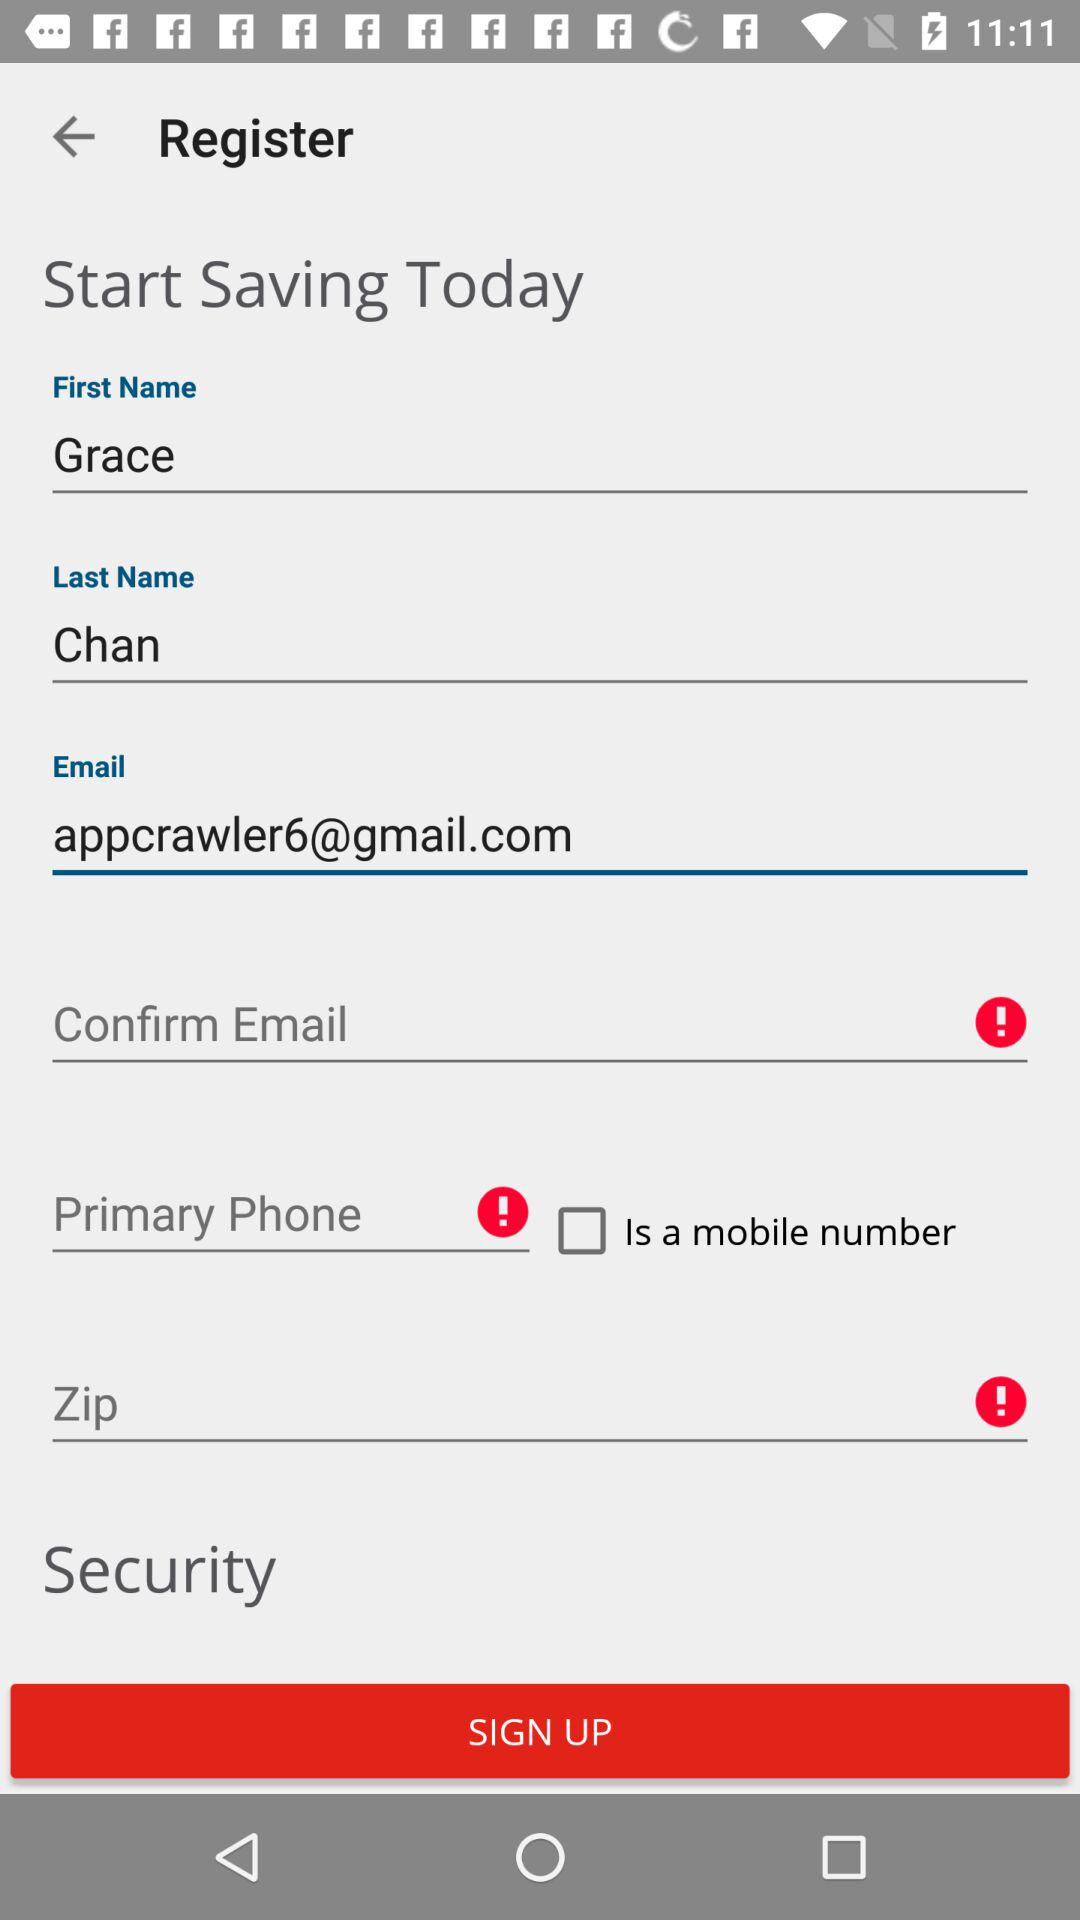What is the name? The name is Grace Chan. 